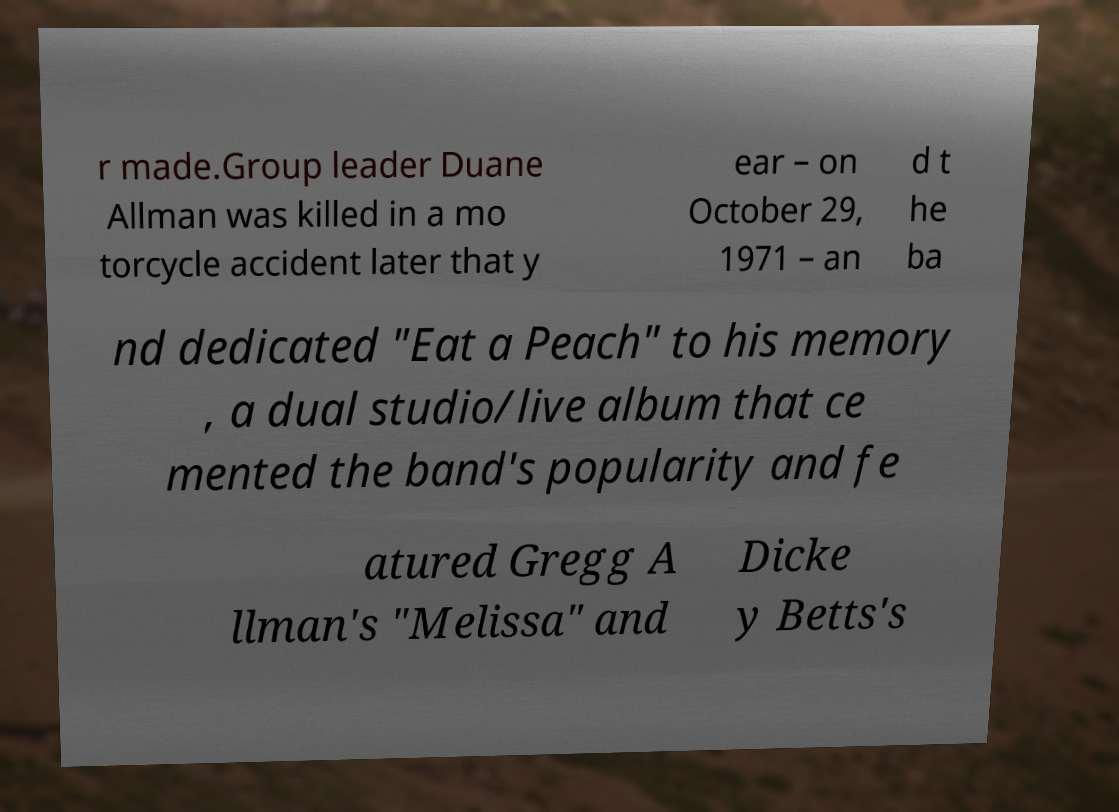Could you extract and type out the text from this image? r made.Group leader Duane Allman was killed in a mo torcycle accident later that y ear – on October 29, 1971 – an d t he ba nd dedicated "Eat a Peach" to his memory , a dual studio/live album that ce mented the band's popularity and fe atured Gregg A llman's "Melissa" and Dicke y Betts's 